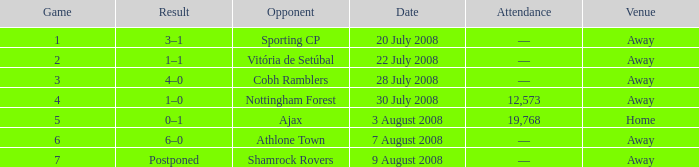What is the result on 20 July 2008? 3–1. 